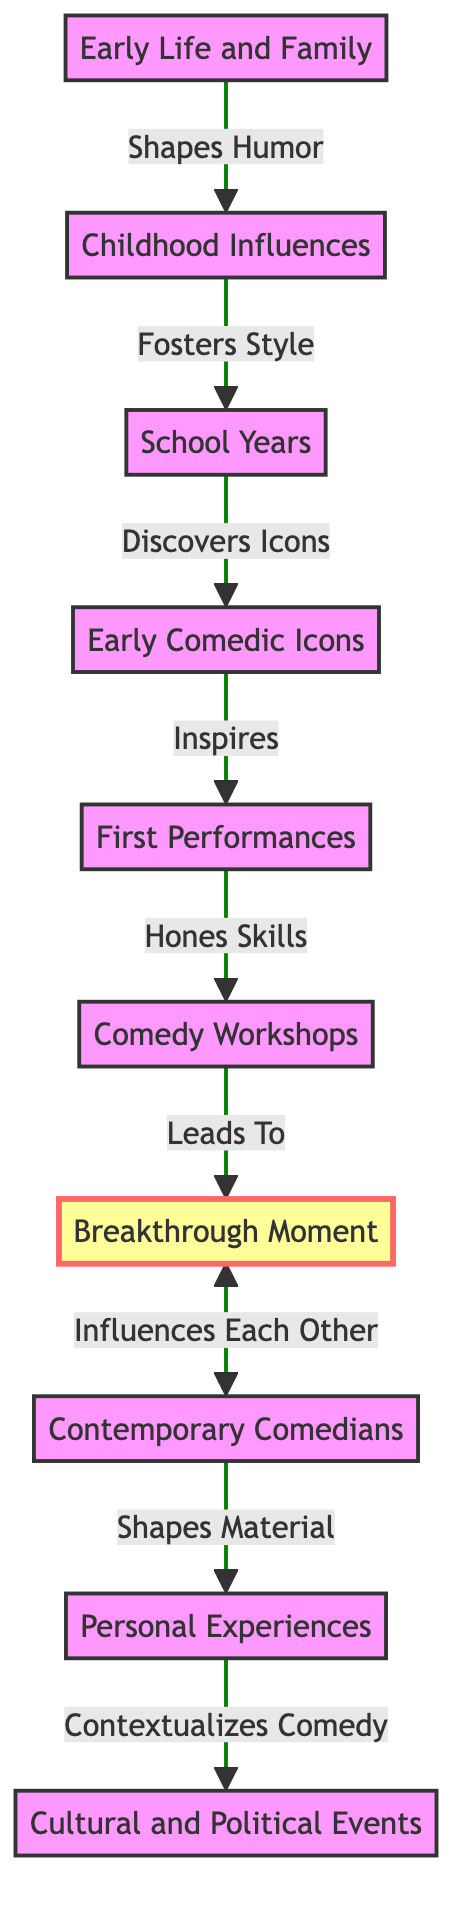What is the first node in the diagram? The first node in the diagram is "Early Life and Family," which is the starting point of the influences on the comedian's style.
Answer: Early Life and Family How many milestones are present in the diagram? There is one milestone indicated in the diagram, which is labeled "Breakthrough Moment."
Answer: 1 What relationship exists between "Comedy Workshops" and "Breakthrough Moment"? The relationship is that "Comedy Workshops" leads to the "Breakthrough Moment," indicating that workshops help achieve this significant point in the comedian's career.
Answer: Leads To Which node follows "Early Comedic Icons"? The node that follows "Early Comedic Icons" is "First Performances," showing a progression from being inspired by icons to performing oneself.
Answer: First Performances What influences contemporary comedians according to the diagram? According to the diagram, contemporary comedians influence each other and are linked to the "Breakthrough Moment," highlighting the interconnectedness in the industry.
Answer: Influences Each Other How do "Personal Experiences" affect "Cultural and Political Events"? "Personal Experiences" shapes the material that a comedian presents, which is then contextualized by "Cultural and Political Events," showing a flow of influence from personal to societal levels.
Answer: Contextualizes Comedy What category is "Breakthrough Moment"? The "Breakthrough Moment" is categorized as a milestone, making it distinct from other nodes in the timeline of influences on the comedian's style.
Answer: milestone Which two nodes are linked directly by "Shapes Humor"? "Early Life and Family" is linked directly to "Childhood Influences" through "Shapes Humor," indicating how one's early life affects their humor style.
Answer: Childhood Influences How would you describe the flow from "First Performances" to "Comedy Workshops"? The flow from "First Performances" to "Comedy Workshops" is that first performances help in honing skills, which is a crucial step in improving comedic ability.
Answer: Hones Skills 